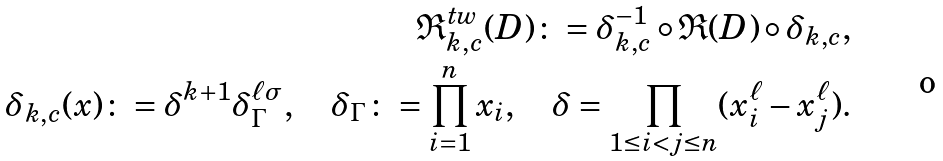<formula> <loc_0><loc_0><loc_500><loc_500>\mathfrak { R } ^ { t w } _ { k , c } ( D ) \colon = \delta _ { k , c } ^ { - 1 } \circ \mathfrak { R } ( D ) \circ \delta _ { k , c } , \\ \delta _ { k , c } ( x ) \colon = \delta ^ { k + 1 } \delta ^ { \ell \sigma } _ { \Gamma } , \quad \delta _ { \Gamma } \colon = \prod _ { i = 1 } ^ { n } x _ { i } , \quad \delta = \prod _ { 1 \leq i < j \leq n } ( x _ { i } ^ { \ell } - x _ { j } ^ { \ell } ) .</formula> 